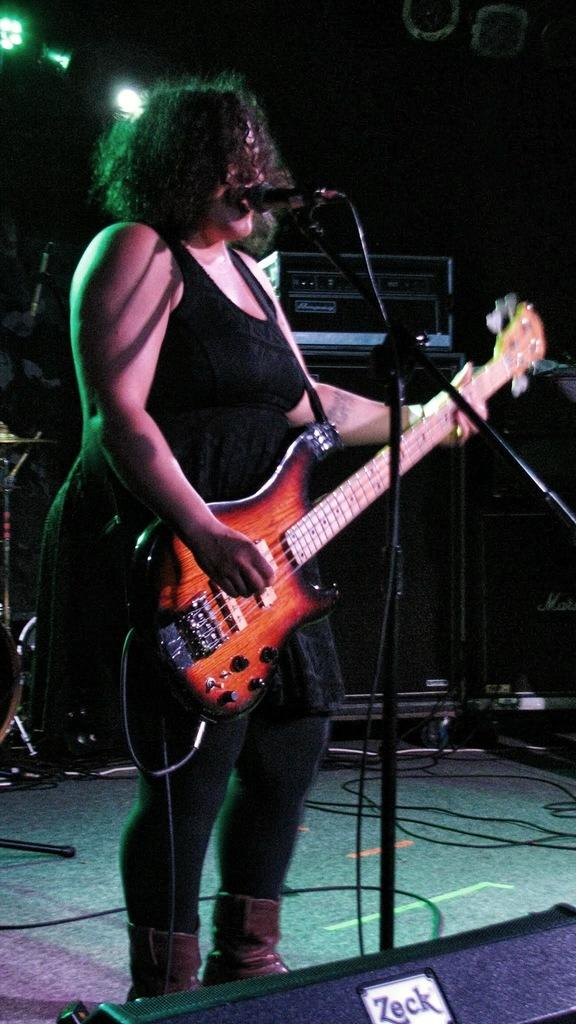Who is the main subject in the image? There is a lady in the image. What is the lady wearing? The lady is wearing a black dress. What is the lady holding in the image? The lady is holding a guitar. What is the lady standing in front of? The lady is standing in front of a microphone. How would you describe the lady's hairstyle? The lady has short hair. What type of pig can be seen in the image? There is no pig present in the image. 